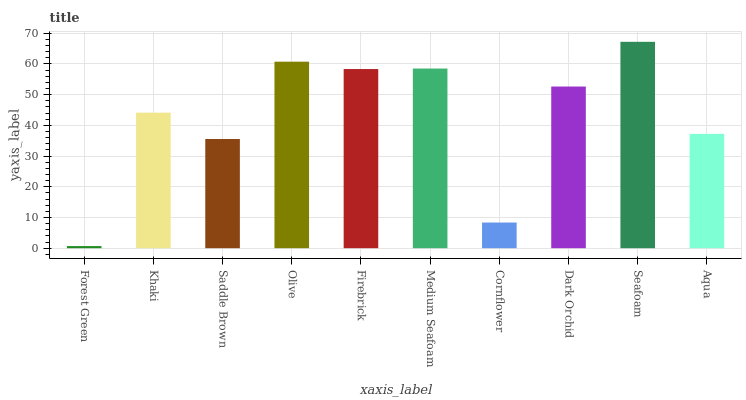Is Forest Green the minimum?
Answer yes or no. Yes. Is Seafoam the maximum?
Answer yes or no. Yes. Is Khaki the minimum?
Answer yes or no. No. Is Khaki the maximum?
Answer yes or no. No. Is Khaki greater than Forest Green?
Answer yes or no. Yes. Is Forest Green less than Khaki?
Answer yes or no. Yes. Is Forest Green greater than Khaki?
Answer yes or no. No. Is Khaki less than Forest Green?
Answer yes or no. No. Is Dark Orchid the high median?
Answer yes or no. Yes. Is Khaki the low median?
Answer yes or no. Yes. Is Cornflower the high median?
Answer yes or no. No. Is Firebrick the low median?
Answer yes or no. No. 